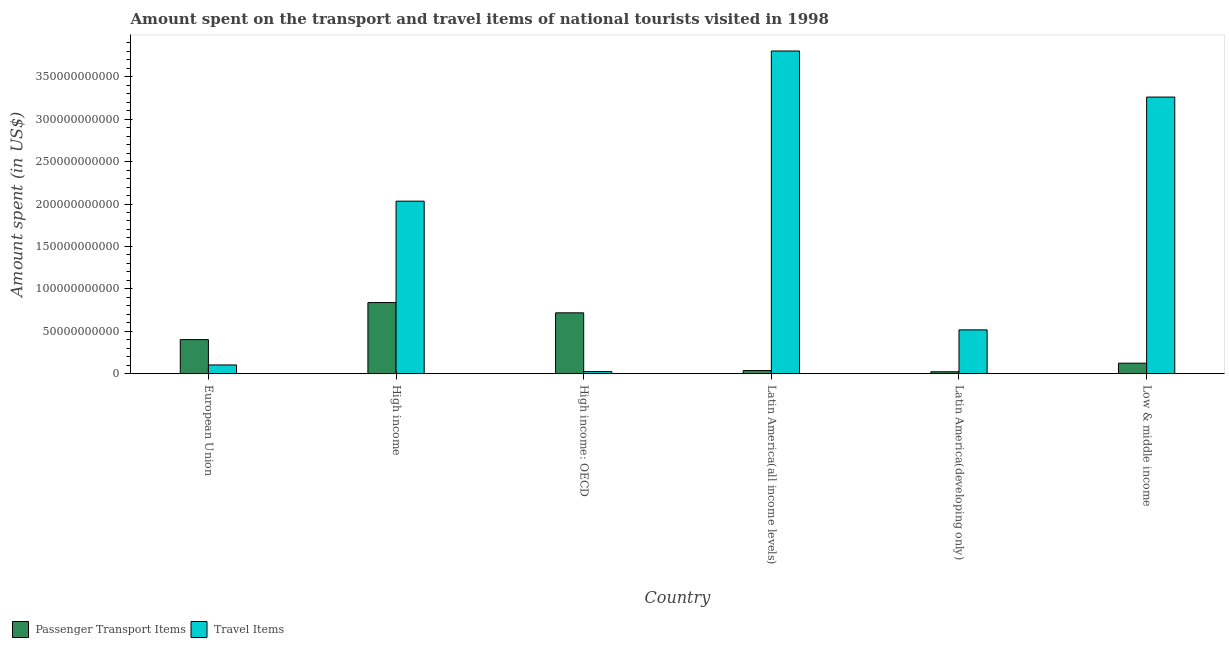How many different coloured bars are there?
Ensure brevity in your answer.  2. How many groups of bars are there?
Your answer should be very brief. 6. Are the number of bars on each tick of the X-axis equal?
Provide a short and direct response. Yes. How many bars are there on the 6th tick from the left?
Keep it short and to the point. 2. What is the label of the 4th group of bars from the left?
Provide a succinct answer. Latin America(all income levels). In how many cases, is the number of bars for a given country not equal to the number of legend labels?
Your answer should be very brief. 0. What is the amount spent on passenger transport items in High income: OECD?
Your answer should be very brief. 7.18e+1. Across all countries, what is the maximum amount spent on passenger transport items?
Your response must be concise. 8.39e+1. Across all countries, what is the minimum amount spent on passenger transport items?
Offer a terse response. 2.32e+09. In which country was the amount spent on passenger transport items minimum?
Offer a very short reply. Latin America(developing only). What is the total amount spent in travel items in the graph?
Give a very brief answer. 9.74e+11. What is the difference between the amount spent on passenger transport items in European Union and that in High income?
Keep it short and to the point. -4.37e+1. What is the difference between the amount spent in travel items in Latin America(developing only) and the amount spent on passenger transport items in Low & middle income?
Provide a succinct answer. 3.92e+1. What is the average amount spent in travel items per country?
Your answer should be very brief. 1.62e+11. What is the difference between the amount spent on passenger transport items and amount spent in travel items in Latin America(all income levels)?
Give a very brief answer. -3.77e+11. In how many countries, is the amount spent in travel items greater than 80000000000 US$?
Provide a short and direct response. 3. What is the ratio of the amount spent on passenger transport items in High income to that in High income: OECD?
Ensure brevity in your answer.  1.17. Is the amount spent in travel items in High income less than that in Latin America(all income levels)?
Your response must be concise. Yes. Is the difference between the amount spent in travel items in European Union and Latin America(all income levels) greater than the difference between the amount spent on passenger transport items in European Union and Latin America(all income levels)?
Keep it short and to the point. No. What is the difference between the highest and the second highest amount spent on passenger transport items?
Provide a succinct answer. 1.21e+1. What is the difference between the highest and the lowest amount spent on passenger transport items?
Your answer should be very brief. 8.15e+1. What does the 2nd bar from the left in Latin America(developing only) represents?
Your answer should be compact. Travel Items. What does the 1st bar from the right in European Union represents?
Keep it short and to the point. Travel Items. Are all the bars in the graph horizontal?
Your answer should be compact. No. What is the difference between two consecutive major ticks on the Y-axis?
Ensure brevity in your answer.  5.00e+1. Does the graph contain grids?
Ensure brevity in your answer.  No. Where does the legend appear in the graph?
Make the answer very short. Bottom left. How are the legend labels stacked?
Keep it short and to the point. Horizontal. What is the title of the graph?
Provide a short and direct response. Amount spent on the transport and travel items of national tourists visited in 1998. Does "Male population" appear as one of the legend labels in the graph?
Your response must be concise. No. What is the label or title of the X-axis?
Make the answer very short. Country. What is the label or title of the Y-axis?
Your answer should be compact. Amount spent (in US$). What is the Amount spent (in US$) of Passenger Transport Items in European Union?
Your response must be concise. 4.02e+1. What is the Amount spent (in US$) in Travel Items in European Union?
Provide a succinct answer. 1.04e+1. What is the Amount spent (in US$) in Passenger Transport Items in High income?
Offer a very short reply. 8.39e+1. What is the Amount spent (in US$) in Travel Items in High income?
Offer a terse response. 2.03e+11. What is the Amount spent (in US$) in Passenger Transport Items in High income: OECD?
Keep it short and to the point. 7.18e+1. What is the Amount spent (in US$) of Travel Items in High income: OECD?
Your answer should be very brief. 2.52e+09. What is the Amount spent (in US$) of Passenger Transport Items in Latin America(all income levels)?
Provide a short and direct response. 3.77e+09. What is the Amount spent (in US$) in Travel Items in Latin America(all income levels)?
Ensure brevity in your answer.  3.80e+11. What is the Amount spent (in US$) in Passenger Transport Items in Latin America(developing only)?
Keep it short and to the point. 2.32e+09. What is the Amount spent (in US$) of Travel Items in Latin America(developing only)?
Offer a terse response. 5.17e+1. What is the Amount spent (in US$) of Passenger Transport Items in Low & middle income?
Provide a short and direct response. 1.24e+1. What is the Amount spent (in US$) in Travel Items in Low & middle income?
Offer a terse response. 3.26e+11. Across all countries, what is the maximum Amount spent (in US$) of Passenger Transport Items?
Make the answer very short. 8.39e+1. Across all countries, what is the maximum Amount spent (in US$) of Travel Items?
Give a very brief answer. 3.80e+11. Across all countries, what is the minimum Amount spent (in US$) of Passenger Transport Items?
Provide a short and direct response. 2.32e+09. Across all countries, what is the minimum Amount spent (in US$) in Travel Items?
Keep it short and to the point. 2.52e+09. What is the total Amount spent (in US$) of Passenger Transport Items in the graph?
Your response must be concise. 2.14e+11. What is the total Amount spent (in US$) of Travel Items in the graph?
Keep it short and to the point. 9.74e+11. What is the difference between the Amount spent (in US$) of Passenger Transport Items in European Union and that in High income?
Offer a very short reply. -4.37e+1. What is the difference between the Amount spent (in US$) in Travel Items in European Union and that in High income?
Ensure brevity in your answer.  -1.93e+11. What is the difference between the Amount spent (in US$) in Passenger Transport Items in European Union and that in High income: OECD?
Make the answer very short. -3.16e+1. What is the difference between the Amount spent (in US$) of Travel Items in European Union and that in High income: OECD?
Provide a succinct answer. 7.83e+09. What is the difference between the Amount spent (in US$) in Passenger Transport Items in European Union and that in Latin America(all income levels)?
Your answer should be compact. 3.64e+1. What is the difference between the Amount spent (in US$) of Travel Items in European Union and that in Latin America(all income levels)?
Ensure brevity in your answer.  -3.70e+11. What is the difference between the Amount spent (in US$) in Passenger Transport Items in European Union and that in Latin America(developing only)?
Ensure brevity in your answer.  3.79e+1. What is the difference between the Amount spent (in US$) of Travel Items in European Union and that in Latin America(developing only)?
Offer a terse response. -4.13e+1. What is the difference between the Amount spent (in US$) of Passenger Transport Items in European Union and that in Low & middle income?
Your answer should be compact. 2.78e+1. What is the difference between the Amount spent (in US$) of Travel Items in European Union and that in Low & middle income?
Give a very brief answer. -3.16e+11. What is the difference between the Amount spent (in US$) in Passenger Transport Items in High income and that in High income: OECD?
Provide a short and direct response. 1.21e+1. What is the difference between the Amount spent (in US$) in Travel Items in High income and that in High income: OECD?
Ensure brevity in your answer.  2.01e+11. What is the difference between the Amount spent (in US$) in Passenger Transport Items in High income and that in Latin America(all income levels)?
Offer a terse response. 8.01e+1. What is the difference between the Amount spent (in US$) in Travel Items in High income and that in Latin America(all income levels)?
Provide a short and direct response. -1.77e+11. What is the difference between the Amount spent (in US$) in Passenger Transport Items in High income and that in Latin America(developing only)?
Your answer should be very brief. 8.15e+1. What is the difference between the Amount spent (in US$) in Travel Items in High income and that in Latin America(developing only)?
Give a very brief answer. 1.52e+11. What is the difference between the Amount spent (in US$) of Passenger Transport Items in High income and that in Low & middle income?
Ensure brevity in your answer.  7.14e+1. What is the difference between the Amount spent (in US$) of Travel Items in High income and that in Low & middle income?
Offer a terse response. -1.23e+11. What is the difference between the Amount spent (in US$) of Passenger Transport Items in High income: OECD and that in Latin America(all income levels)?
Your answer should be compact. 6.80e+1. What is the difference between the Amount spent (in US$) in Travel Items in High income: OECD and that in Latin America(all income levels)?
Make the answer very short. -3.78e+11. What is the difference between the Amount spent (in US$) of Passenger Transport Items in High income: OECD and that in Latin America(developing only)?
Your answer should be very brief. 6.94e+1. What is the difference between the Amount spent (in US$) of Travel Items in High income: OECD and that in Latin America(developing only)?
Make the answer very short. -4.92e+1. What is the difference between the Amount spent (in US$) of Passenger Transport Items in High income: OECD and that in Low & middle income?
Your response must be concise. 5.93e+1. What is the difference between the Amount spent (in US$) of Travel Items in High income: OECD and that in Low & middle income?
Ensure brevity in your answer.  -3.23e+11. What is the difference between the Amount spent (in US$) of Passenger Transport Items in Latin America(all income levels) and that in Latin America(developing only)?
Offer a terse response. 1.45e+09. What is the difference between the Amount spent (in US$) in Travel Items in Latin America(all income levels) and that in Latin America(developing only)?
Ensure brevity in your answer.  3.29e+11. What is the difference between the Amount spent (in US$) of Passenger Transport Items in Latin America(all income levels) and that in Low & middle income?
Ensure brevity in your answer.  -8.68e+09. What is the difference between the Amount spent (in US$) of Travel Items in Latin America(all income levels) and that in Low & middle income?
Offer a very short reply. 5.43e+1. What is the difference between the Amount spent (in US$) in Passenger Transport Items in Latin America(developing only) and that in Low & middle income?
Provide a succinct answer. -1.01e+1. What is the difference between the Amount spent (in US$) of Travel Items in Latin America(developing only) and that in Low & middle income?
Offer a very short reply. -2.74e+11. What is the difference between the Amount spent (in US$) of Passenger Transport Items in European Union and the Amount spent (in US$) of Travel Items in High income?
Keep it short and to the point. -1.63e+11. What is the difference between the Amount spent (in US$) of Passenger Transport Items in European Union and the Amount spent (in US$) of Travel Items in High income: OECD?
Keep it short and to the point. 3.77e+1. What is the difference between the Amount spent (in US$) of Passenger Transport Items in European Union and the Amount spent (in US$) of Travel Items in Latin America(all income levels)?
Offer a terse response. -3.40e+11. What is the difference between the Amount spent (in US$) in Passenger Transport Items in European Union and the Amount spent (in US$) in Travel Items in Latin America(developing only)?
Offer a very short reply. -1.15e+1. What is the difference between the Amount spent (in US$) in Passenger Transport Items in European Union and the Amount spent (in US$) in Travel Items in Low & middle income?
Ensure brevity in your answer.  -2.86e+11. What is the difference between the Amount spent (in US$) of Passenger Transport Items in High income and the Amount spent (in US$) of Travel Items in High income: OECD?
Make the answer very short. 8.13e+1. What is the difference between the Amount spent (in US$) of Passenger Transport Items in High income and the Amount spent (in US$) of Travel Items in Latin America(all income levels)?
Your answer should be very brief. -2.96e+11. What is the difference between the Amount spent (in US$) of Passenger Transport Items in High income and the Amount spent (in US$) of Travel Items in Latin America(developing only)?
Make the answer very short. 3.22e+1. What is the difference between the Amount spent (in US$) of Passenger Transport Items in High income and the Amount spent (in US$) of Travel Items in Low & middle income?
Give a very brief answer. -2.42e+11. What is the difference between the Amount spent (in US$) of Passenger Transport Items in High income: OECD and the Amount spent (in US$) of Travel Items in Latin America(all income levels)?
Give a very brief answer. -3.09e+11. What is the difference between the Amount spent (in US$) in Passenger Transport Items in High income: OECD and the Amount spent (in US$) in Travel Items in Latin America(developing only)?
Keep it short and to the point. 2.01e+1. What is the difference between the Amount spent (in US$) of Passenger Transport Items in High income: OECD and the Amount spent (in US$) of Travel Items in Low & middle income?
Offer a very short reply. -2.54e+11. What is the difference between the Amount spent (in US$) of Passenger Transport Items in Latin America(all income levels) and the Amount spent (in US$) of Travel Items in Latin America(developing only)?
Provide a succinct answer. -4.79e+1. What is the difference between the Amount spent (in US$) of Passenger Transport Items in Latin America(all income levels) and the Amount spent (in US$) of Travel Items in Low & middle income?
Provide a succinct answer. -3.22e+11. What is the difference between the Amount spent (in US$) in Passenger Transport Items in Latin America(developing only) and the Amount spent (in US$) in Travel Items in Low & middle income?
Ensure brevity in your answer.  -3.24e+11. What is the average Amount spent (in US$) of Passenger Transport Items per country?
Make the answer very short. 3.57e+1. What is the average Amount spent (in US$) of Travel Items per country?
Your answer should be compact. 1.62e+11. What is the difference between the Amount spent (in US$) in Passenger Transport Items and Amount spent (in US$) in Travel Items in European Union?
Provide a short and direct response. 2.98e+1. What is the difference between the Amount spent (in US$) of Passenger Transport Items and Amount spent (in US$) of Travel Items in High income?
Keep it short and to the point. -1.19e+11. What is the difference between the Amount spent (in US$) in Passenger Transport Items and Amount spent (in US$) in Travel Items in High income: OECD?
Offer a terse response. 6.92e+1. What is the difference between the Amount spent (in US$) of Passenger Transport Items and Amount spent (in US$) of Travel Items in Latin America(all income levels)?
Offer a terse response. -3.77e+11. What is the difference between the Amount spent (in US$) of Passenger Transport Items and Amount spent (in US$) of Travel Items in Latin America(developing only)?
Ensure brevity in your answer.  -4.94e+1. What is the difference between the Amount spent (in US$) in Passenger Transport Items and Amount spent (in US$) in Travel Items in Low & middle income?
Offer a very short reply. -3.14e+11. What is the ratio of the Amount spent (in US$) in Passenger Transport Items in European Union to that in High income?
Ensure brevity in your answer.  0.48. What is the ratio of the Amount spent (in US$) of Travel Items in European Union to that in High income?
Your response must be concise. 0.05. What is the ratio of the Amount spent (in US$) of Passenger Transport Items in European Union to that in High income: OECD?
Offer a terse response. 0.56. What is the ratio of the Amount spent (in US$) in Travel Items in European Union to that in High income: OECD?
Provide a short and direct response. 4.1. What is the ratio of the Amount spent (in US$) in Passenger Transport Items in European Union to that in Latin America(all income levels)?
Make the answer very short. 10.66. What is the ratio of the Amount spent (in US$) in Travel Items in European Union to that in Latin America(all income levels)?
Make the answer very short. 0.03. What is the ratio of the Amount spent (in US$) in Passenger Transport Items in European Union to that in Latin America(developing only)?
Offer a terse response. 17.34. What is the ratio of the Amount spent (in US$) in Travel Items in European Union to that in Latin America(developing only)?
Your answer should be compact. 0.2. What is the ratio of the Amount spent (in US$) of Passenger Transport Items in European Union to that in Low & middle income?
Your answer should be very brief. 3.23. What is the ratio of the Amount spent (in US$) in Travel Items in European Union to that in Low & middle income?
Keep it short and to the point. 0.03. What is the ratio of the Amount spent (in US$) of Passenger Transport Items in High income to that in High income: OECD?
Offer a very short reply. 1.17. What is the ratio of the Amount spent (in US$) in Travel Items in High income to that in High income: OECD?
Ensure brevity in your answer.  80.54. What is the ratio of the Amount spent (in US$) in Passenger Transport Items in High income to that in Latin America(all income levels)?
Your answer should be compact. 22.25. What is the ratio of the Amount spent (in US$) in Travel Items in High income to that in Latin America(all income levels)?
Your answer should be very brief. 0.53. What is the ratio of the Amount spent (in US$) in Passenger Transport Items in High income to that in Latin America(developing only)?
Keep it short and to the point. 36.18. What is the ratio of the Amount spent (in US$) in Travel Items in High income to that in Latin America(developing only)?
Make the answer very short. 3.93. What is the ratio of the Amount spent (in US$) in Passenger Transport Items in High income to that in Low & middle income?
Provide a short and direct response. 6.74. What is the ratio of the Amount spent (in US$) of Travel Items in High income to that in Low & middle income?
Ensure brevity in your answer.  0.62. What is the ratio of the Amount spent (in US$) of Passenger Transport Items in High income: OECD to that in Latin America(all income levels)?
Offer a very short reply. 19.03. What is the ratio of the Amount spent (in US$) in Travel Items in High income: OECD to that in Latin America(all income levels)?
Ensure brevity in your answer.  0.01. What is the ratio of the Amount spent (in US$) of Passenger Transport Items in High income: OECD to that in Latin America(developing only)?
Keep it short and to the point. 30.96. What is the ratio of the Amount spent (in US$) in Travel Items in High income: OECD to that in Latin America(developing only)?
Ensure brevity in your answer.  0.05. What is the ratio of the Amount spent (in US$) of Passenger Transport Items in High income: OECD to that in Low & middle income?
Offer a very short reply. 5.76. What is the ratio of the Amount spent (in US$) in Travel Items in High income: OECD to that in Low & middle income?
Offer a terse response. 0.01. What is the ratio of the Amount spent (in US$) of Passenger Transport Items in Latin America(all income levels) to that in Latin America(developing only)?
Your answer should be very brief. 1.63. What is the ratio of the Amount spent (in US$) of Travel Items in Latin America(all income levels) to that in Latin America(developing only)?
Your answer should be very brief. 7.36. What is the ratio of the Amount spent (in US$) of Passenger Transport Items in Latin America(all income levels) to that in Low & middle income?
Give a very brief answer. 0.3. What is the ratio of the Amount spent (in US$) of Travel Items in Latin America(all income levels) to that in Low & middle income?
Your answer should be compact. 1.17. What is the ratio of the Amount spent (in US$) in Passenger Transport Items in Latin America(developing only) to that in Low & middle income?
Provide a succinct answer. 0.19. What is the ratio of the Amount spent (in US$) in Travel Items in Latin America(developing only) to that in Low & middle income?
Offer a very short reply. 0.16. What is the difference between the highest and the second highest Amount spent (in US$) of Passenger Transport Items?
Your answer should be very brief. 1.21e+1. What is the difference between the highest and the second highest Amount spent (in US$) of Travel Items?
Offer a very short reply. 5.43e+1. What is the difference between the highest and the lowest Amount spent (in US$) in Passenger Transport Items?
Provide a succinct answer. 8.15e+1. What is the difference between the highest and the lowest Amount spent (in US$) in Travel Items?
Keep it short and to the point. 3.78e+11. 